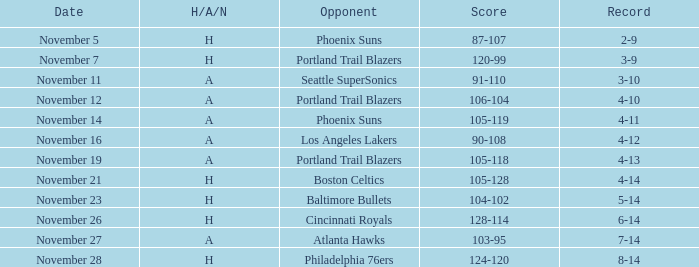What was the Opponent when the Cavaliers had a Record of 3-9? Portland Trail Blazers. Could you parse the entire table? {'header': ['Date', 'H/A/N', 'Opponent', 'Score', 'Record'], 'rows': [['November 5', 'H', 'Phoenix Suns', '87-107', '2-9'], ['November 7', 'H', 'Portland Trail Blazers', '120-99', '3-9'], ['November 11', 'A', 'Seattle SuperSonics', '91-110', '3-10'], ['November 12', 'A', 'Portland Trail Blazers', '106-104', '4-10'], ['November 14', 'A', 'Phoenix Suns', '105-119', '4-11'], ['November 16', 'A', 'Los Angeles Lakers', '90-108', '4-12'], ['November 19', 'A', 'Portland Trail Blazers', '105-118', '4-13'], ['November 21', 'H', 'Boston Celtics', '105-128', '4-14'], ['November 23', 'H', 'Baltimore Bullets', '104-102', '5-14'], ['November 26', 'H', 'Cincinnati Royals', '128-114', '6-14'], ['November 27', 'A', 'Atlanta Hawks', '103-95', '7-14'], ['November 28', 'H', 'Philadelphia 76ers', '124-120', '8-14']]} 